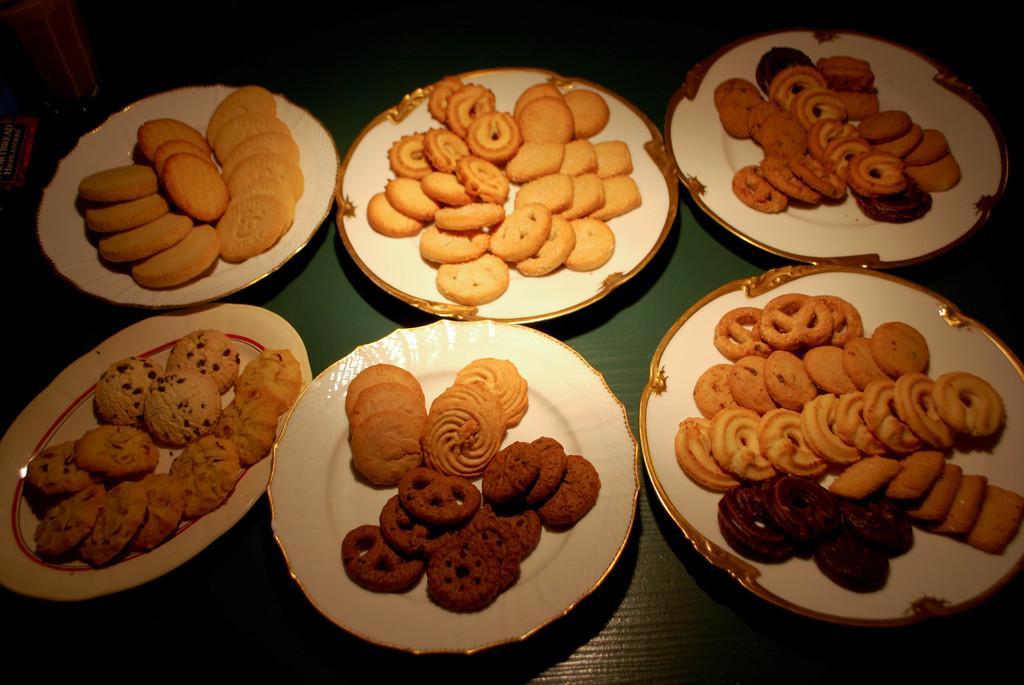In one or two sentences, can you explain what this image depicts? In this image we can see a group of plates containing biscuits and cookies placed on the surface. In the left side of the image we can see a glass and an object. 